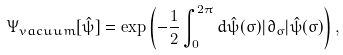<formula> <loc_0><loc_0><loc_500><loc_500>\Psi _ { v a c u u m } [ \hat { \psi } ] = \exp \left ( - { \frac { 1 } { 2 } } \int _ { 0 } ^ { 2 \pi } d \hat { \psi } ( \sigma ) | \partial _ { \sigma } | \hat { \psi } ( \sigma ) \right ) ,</formula> 